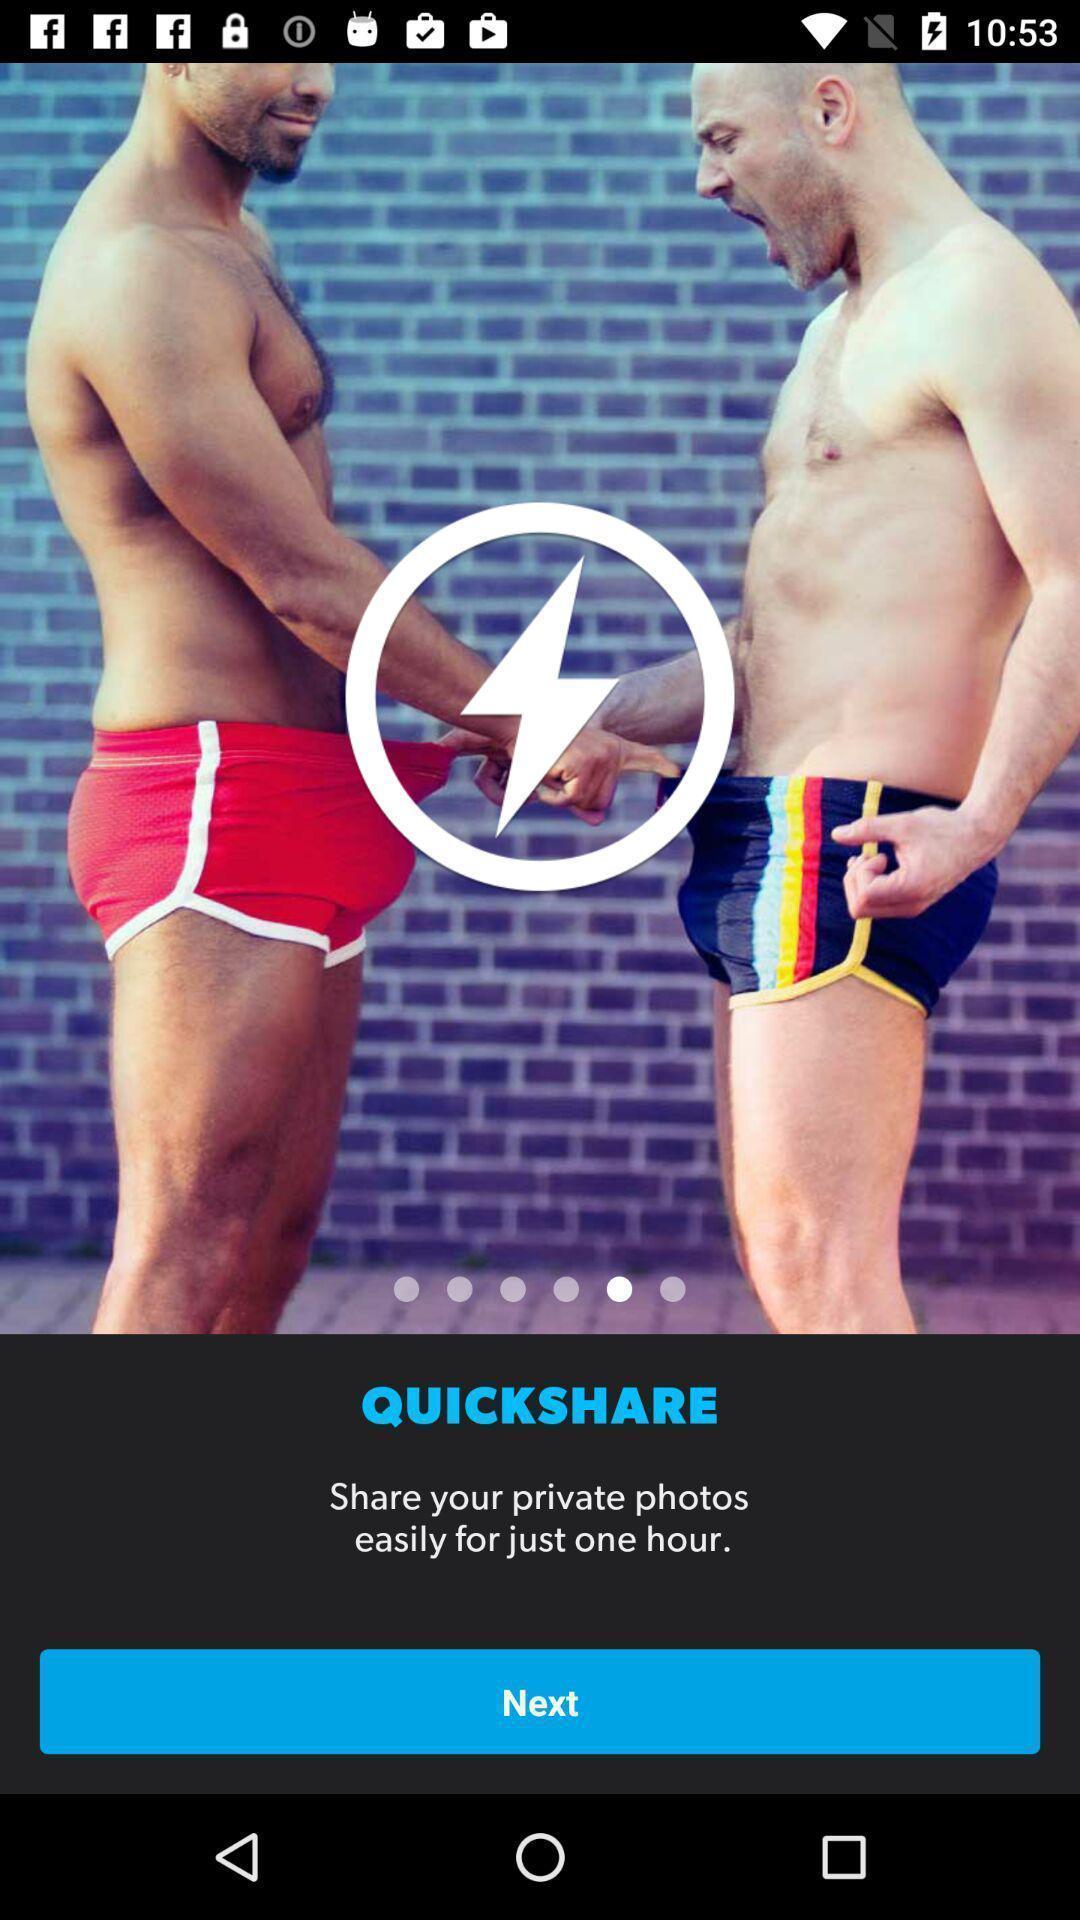Provide a textual representation of this image. Welcome page of a social app. 